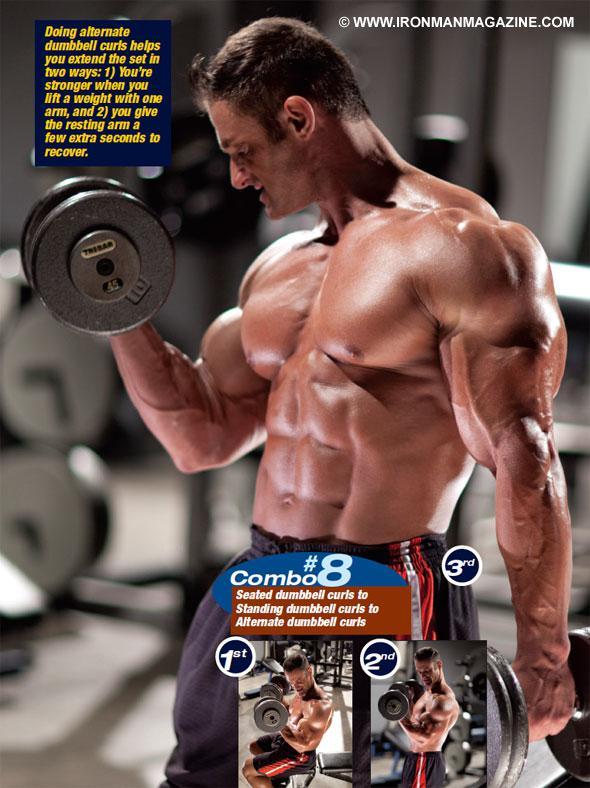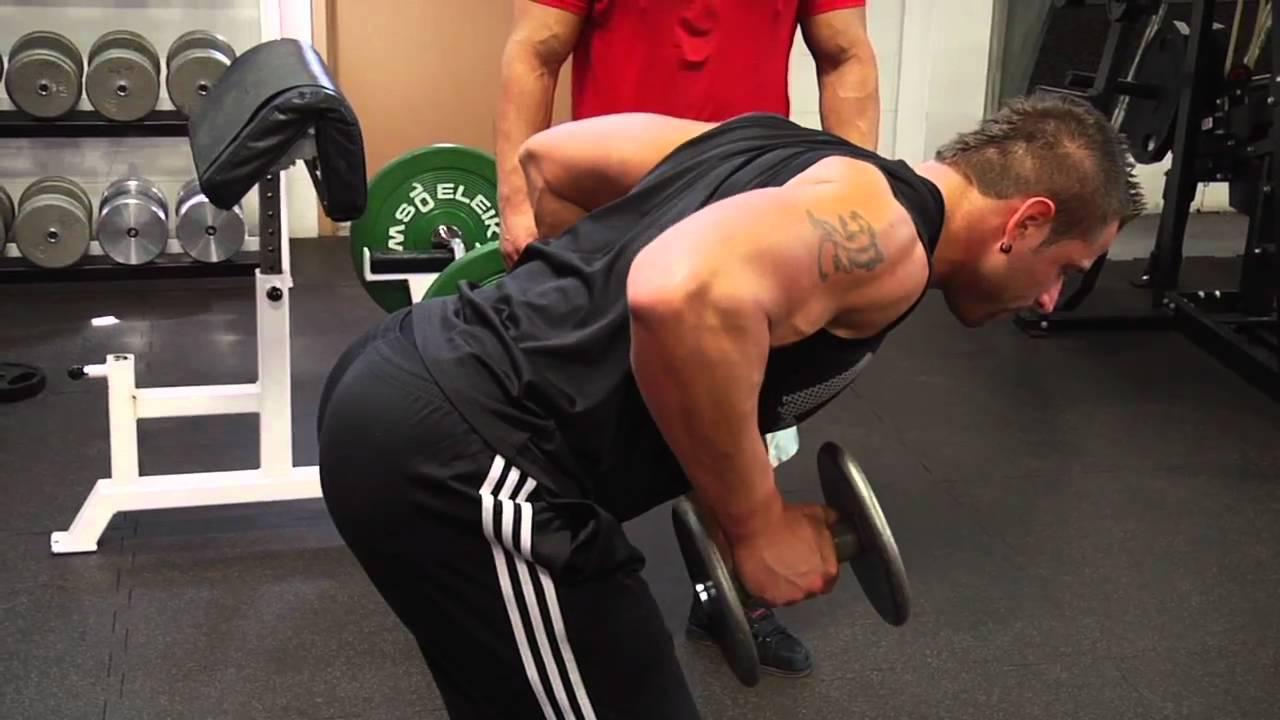The first image is the image on the left, the second image is the image on the right. For the images shown, is this caption "At least one image features a woman." true? Answer yes or no. No. 